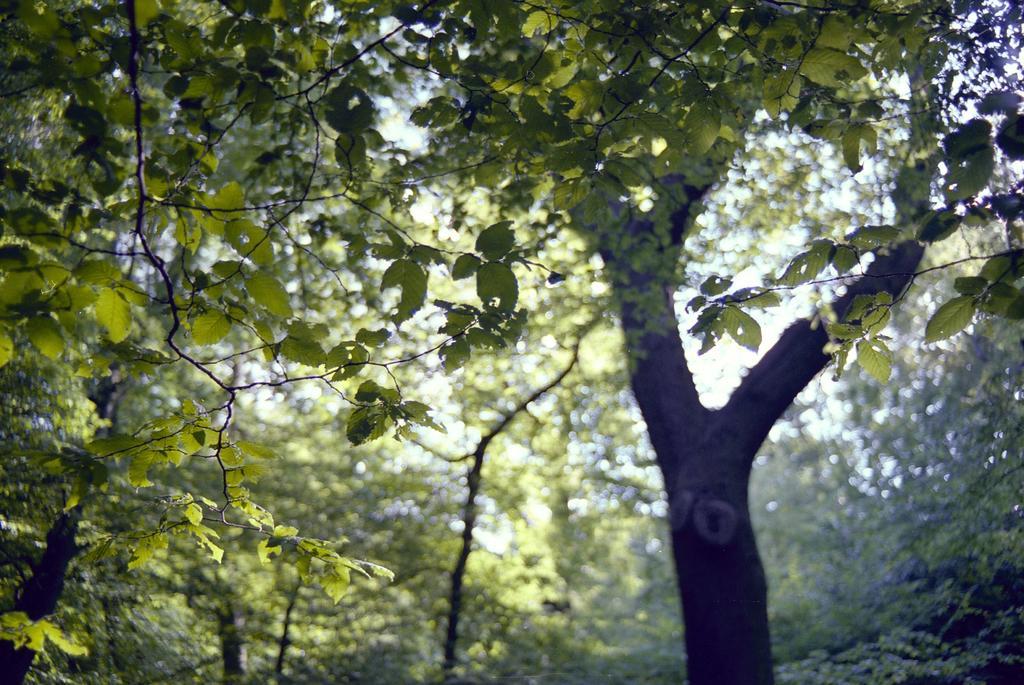Describe this image in one or two sentences. In this picture we can see many trees. On the left we can see the leaves. In the background there is a sky. 